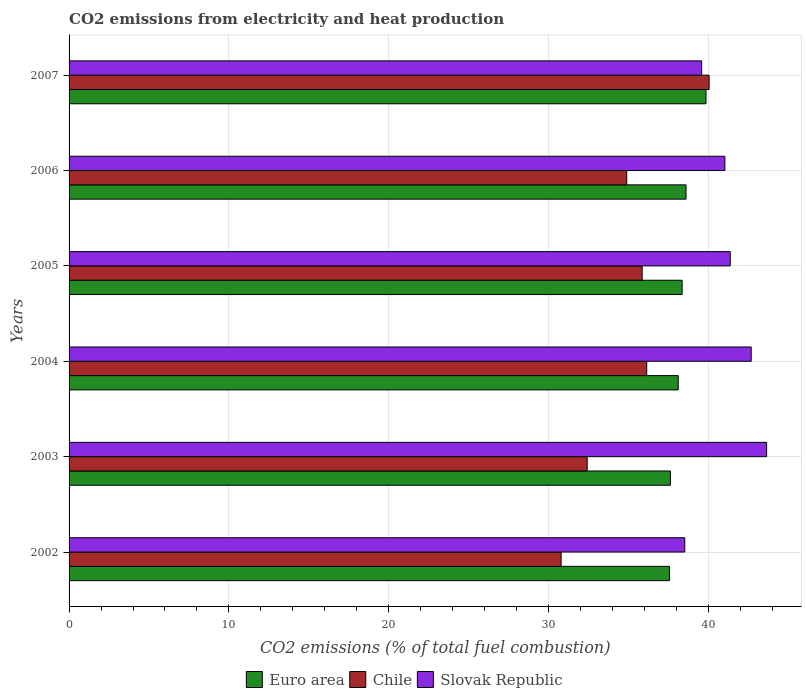How many groups of bars are there?
Make the answer very short. 6. Are the number of bars on each tick of the Y-axis equal?
Ensure brevity in your answer.  Yes. How many bars are there on the 1st tick from the top?
Make the answer very short. 3. What is the label of the 5th group of bars from the top?
Offer a very short reply. 2003. What is the amount of CO2 emitted in Euro area in 2003?
Ensure brevity in your answer.  37.62. Across all years, what is the maximum amount of CO2 emitted in Euro area?
Your answer should be compact. 39.85. Across all years, what is the minimum amount of CO2 emitted in Euro area?
Give a very brief answer. 37.57. In which year was the amount of CO2 emitted in Slovak Republic minimum?
Offer a terse response. 2002. What is the total amount of CO2 emitted in Chile in the graph?
Your response must be concise. 210.12. What is the difference between the amount of CO2 emitted in Slovak Republic in 2002 and that in 2006?
Offer a very short reply. -2.51. What is the difference between the amount of CO2 emitted in Euro area in 2004 and the amount of CO2 emitted in Slovak Republic in 2006?
Your answer should be very brief. -2.92. What is the average amount of CO2 emitted in Euro area per year?
Your answer should be compact. 38.35. In the year 2006, what is the difference between the amount of CO2 emitted in Euro area and amount of CO2 emitted in Slovak Republic?
Give a very brief answer. -2.43. What is the ratio of the amount of CO2 emitted in Slovak Republic in 2003 to that in 2006?
Your answer should be very brief. 1.06. Is the amount of CO2 emitted in Slovak Republic in 2004 less than that in 2007?
Make the answer very short. No. Is the difference between the amount of CO2 emitted in Euro area in 2002 and 2003 greater than the difference between the amount of CO2 emitted in Slovak Republic in 2002 and 2003?
Offer a terse response. Yes. What is the difference between the highest and the second highest amount of CO2 emitted in Euro area?
Offer a terse response. 1.25. What is the difference between the highest and the lowest amount of CO2 emitted in Euro area?
Ensure brevity in your answer.  2.28. In how many years, is the amount of CO2 emitted in Euro area greater than the average amount of CO2 emitted in Euro area taken over all years?
Offer a terse response. 3. Is the sum of the amount of CO2 emitted in Slovak Republic in 2003 and 2006 greater than the maximum amount of CO2 emitted in Euro area across all years?
Your answer should be very brief. Yes. What does the 1st bar from the top in 2005 represents?
Your answer should be very brief. Slovak Republic. What does the 3rd bar from the bottom in 2003 represents?
Your answer should be compact. Slovak Republic. Where does the legend appear in the graph?
Give a very brief answer. Bottom center. How many legend labels are there?
Your answer should be compact. 3. How are the legend labels stacked?
Keep it short and to the point. Horizontal. What is the title of the graph?
Offer a very short reply. CO2 emissions from electricity and heat production. What is the label or title of the X-axis?
Provide a succinct answer. CO2 emissions (% of total fuel combustion). What is the CO2 emissions (% of total fuel combustion) in Euro area in 2002?
Give a very brief answer. 37.57. What is the CO2 emissions (% of total fuel combustion) of Chile in 2002?
Your answer should be compact. 30.78. What is the CO2 emissions (% of total fuel combustion) in Slovak Republic in 2002?
Provide a succinct answer. 38.52. What is the CO2 emissions (% of total fuel combustion) of Euro area in 2003?
Make the answer very short. 37.62. What is the CO2 emissions (% of total fuel combustion) of Chile in 2003?
Your answer should be compact. 32.42. What is the CO2 emissions (% of total fuel combustion) of Slovak Republic in 2003?
Offer a very short reply. 43.64. What is the CO2 emissions (% of total fuel combustion) of Euro area in 2004?
Offer a terse response. 38.11. What is the CO2 emissions (% of total fuel combustion) of Chile in 2004?
Provide a short and direct response. 36.14. What is the CO2 emissions (% of total fuel combustion) in Slovak Republic in 2004?
Provide a succinct answer. 42.68. What is the CO2 emissions (% of total fuel combustion) in Euro area in 2005?
Offer a very short reply. 38.36. What is the CO2 emissions (% of total fuel combustion) in Chile in 2005?
Provide a succinct answer. 35.85. What is the CO2 emissions (% of total fuel combustion) in Slovak Republic in 2005?
Your response must be concise. 41.36. What is the CO2 emissions (% of total fuel combustion) of Euro area in 2006?
Offer a very short reply. 38.6. What is the CO2 emissions (% of total fuel combustion) of Chile in 2006?
Provide a short and direct response. 34.89. What is the CO2 emissions (% of total fuel combustion) in Slovak Republic in 2006?
Your answer should be compact. 41.03. What is the CO2 emissions (% of total fuel combustion) of Euro area in 2007?
Offer a very short reply. 39.85. What is the CO2 emissions (% of total fuel combustion) of Chile in 2007?
Provide a succinct answer. 40.04. What is the CO2 emissions (% of total fuel combustion) of Slovak Republic in 2007?
Give a very brief answer. 39.58. Across all years, what is the maximum CO2 emissions (% of total fuel combustion) of Euro area?
Offer a very short reply. 39.85. Across all years, what is the maximum CO2 emissions (% of total fuel combustion) in Chile?
Keep it short and to the point. 40.04. Across all years, what is the maximum CO2 emissions (% of total fuel combustion) of Slovak Republic?
Your answer should be very brief. 43.64. Across all years, what is the minimum CO2 emissions (% of total fuel combustion) in Euro area?
Keep it short and to the point. 37.57. Across all years, what is the minimum CO2 emissions (% of total fuel combustion) of Chile?
Ensure brevity in your answer.  30.78. Across all years, what is the minimum CO2 emissions (% of total fuel combustion) of Slovak Republic?
Provide a succinct answer. 38.52. What is the total CO2 emissions (% of total fuel combustion) in Euro area in the graph?
Make the answer very short. 230.1. What is the total CO2 emissions (% of total fuel combustion) in Chile in the graph?
Make the answer very short. 210.12. What is the total CO2 emissions (% of total fuel combustion) in Slovak Republic in the graph?
Give a very brief answer. 246.81. What is the difference between the CO2 emissions (% of total fuel combustion) in Euro area in 2002 and that in 2003?
Keep it short and to the point. -0.05. What is the difference between the CO2 emissions (% of total fuel combustion) of Chile in 2002 and that in 2003?
Give a very brief answer. -1.63. What is the difference between the CO2 emissions (% of total fuel combustion) of Slovak Republic in 2002 and that in 2003?
Ensure brevity in your answer.  -5.12. What is the difference between the CO2 emissions (% of total fuel combustion) in Euro area in 2002 and that in 2004?
Provide a succinct answer. -0.54. What is the difference between the CO2 emissions (% of total fuel combustion) in Chile in 2002 and that in 2004?
Your answer should be very brief. -5.36. What is the difference between the CO2 emissions (% of total fuel combustion) of Slovak Republic in 2002 and that in 2004?
Ensure brevity in your answer.  -4.16. What is the difference between the CO2 emissions (% of total fuel combustion) in Euro area in 2002 and that in 2005?
Offer a terse response. -0.79. What is the difference between the CO2 emissions (% of total fuel combustion) in Chile in 2002 and that in 2005?
Make the answer very short. -5.07. What is the difference between the CO2 emissions (% of total fuel combustion) of Slovak Republic in 2002 and that in 2005?
Your answer should be compact. -2.84. What is the difference between the CO2 emissions (% of total fuel combustion) of Euro area in 2002 and that in 2006?
Make the answer very short. -1.03. What is the difference between the CO2 emissions (% of total fuel combustion) of Chile in 2002 and that in 2006?
Your answer should be compact. -4.1. What is the difference between the CO2 emissions (% of total fuel combustion) in Slovak Republic in 2002 and that in 2006?
Ensure brevity in your answer.  -2.51. What is the difference between the CO2 emissions (% of total fuel combustion) in Euro area in 2002 and that in 2007?
Keep it short and to the point. -2.28. What is the difference between the CO2 emissions (% of total fuel combustion) of Chile in 2002 and that in 2007?
Provide a succinct answer. -9.26. What is the difference between the CO2 emissions (% of total fuel combustion) of Slovak Republic in 2002 and that in 2007?
Keep it short and to the point. -1.06. What is the difference between the CO2 emissions (% of total fuel combustion) in Euro area in 2003 and that in 2004?
Offer a terse response. -0.49. What is the difference between the CO2 emissions (% of total fuel combustion) in Chile in 2003 and that in 2004?
Keep it short and to the point. -3.72. What is the difference between the CO2 emissions (% of total fuel combustion) in Slovak Republic in 2003 and that in 2004?
Provide a succinct answer. 0.96. What is the difference between the CO2 emissions (% of total fuel combustion) in Euro area in 2003 and that in 2005?
Provide a short and direct response. -0.73. What is the difference between the CO2 emissions (% of total fuel combustion) of Chile in 2003 and that in 2005?
Keep it short and to the point. -3.44. What is the difference between the CO2 emissions (% of total fuel combustion) of Slovak Republic in 2003 and that in 2005?
Offer a very short reply. 2.28. What is the difference between the CO2 emissions (% of total fuel combustion) in Euro area in 2003 and that in 2006?
Provide a short and direct response. -0.98. What is the difference between the CO2 emissions (% of total fuel combustion) of Chile in 2003 and that in 2006?
Keep it short and to the point. -2.47. What is the difference between the CO2 emissions (% of total fuel combustion) in Slovak Republic in 2003 and that in 2006?
Offer a terse response. 2.61. What is the difference between the CO2 emissions (% of total fuel combustion) in Euro area in 2003 and that in 2007?
Give a very brief answer. -2.23. What is the difference between the CO2 emissions (% of total fuel combustion) of Chile in 2003 and that in 2007?
Your response must be concise. -7.63. What is the difference between the CO2 emissions (% of total fuel combustion) of Slovak Republic in 2003 and that in 2007?
Provide a short and direct response. 4.06. What is the difference between the CO2 emissions (% of total fuel combustion) of Euro area in 2004 and that in 2005?
Keep it short and to the point. -0.24. What is the difference between the CO2 emissions (% of total fuel combustion) in Chile in 2004 and that in 2005?
Make the answer very short. 0.29. What is the difference between the CO2 emissions (% of total fuel combustion) in Slovak Republic in 2004 and that in 2005?
Ensure brevity in your answer.  1.31. What is the difference between the CO2 emissions (% of total fuel combustion) in Euro area in 2004 and that in 2006?
Your answer should be very brief. -0.49. What is the difference between the CO2 emissions (% of total fuel combustion) in Chile in 2004 and that in 2006?
Your response must be concise. 1.25. What is the difference between the CO2 emissions (% of total fuel combustion) in Slovak Republic in 2004 and that in 2006?
Provide a succinct answer. 1.65. What is the difference between the CO2 emissions (% of total fuel combustion) of Euro area in 2004 and that in 2007?
Make the answer very short. -1.74. What is the difference between the CO2 emissions (% of total fuel combustion) in Chile in 2004 and that in 2007?
Your answer should be very brief. -3.9. What is the difference between the CO2 emissions (% of total fuel combustion) of Slovak Republic in 2004 and that in 2007?
Provide a short and direct response. 3.1. What is the difference between the CO2 emissions (% of total fuel combustion) of Euro area in 2005 and that in 2006?
Ensure brevity in your answer.  -0.24. What is the difference between the CO2 emissions (% of total fuel combustion) of Chile in 2005 and that in 2006?
Make the answer very short. 0.97. What is the difference between the CO2 emissions (% of total fuel combustion) of Slovak Republic in 2005 and that in 2006?
Your answer should be compact. 0.33. What is the difference between the CO2 emissions (% of total fuel combustion) of Euro area in 2005 and that in 2007?
Offer a very short reply. -1.49. What is the difference between the CO2 emissions (% of total fuel combustion) of Chile in 2005 and that in 2007?
Your response must be concise. -4.19. What is the difference between the CO2 emissions (% of total fuel combustion) in Slovak Republic in 2005 and that in 2007?
Your response must be concise. 1.79. What is the difference between the CO2 emissions (% of total fuel combustion) of Euro area in 2006 and that in 2007?
Keep it short and to the point. -1.25. What is the difference between the CO2 emissions (% of total fuel combustion) in Chile in 2006 and that in 2007?
Your answer should be very brief. -5.16. What is the difference between the CO2 emissions (% of total fuel combustion) of Slovak Republic in 2006 and that in 2007?
Make the answer very short. 1.45. What is the difference between the CO2 emissions (% of total fuel combustion) in Euro area in 2002 and the CO2 emissions (% of total fuel combustion) in Chile in 2003?
Provide a succinct answer. 5.15. What is the difference between the CO2 emissions (% of total fuel combustion) in Euro area in 2002 and the CO2 emissions (% of total fuel combustion) in Slovak Republic in 2003?
Your response must be concise. -6.07. What is the difference between the CO2 emissions (% of total fuel combustion) of Chile in 2002 and the CO2 emissions (% of total fuel combustion) of Slovak Republic in 2003?
Your answer should be compact. -12.86. What is the difference between the CO2 emissions (% of total fuel combustion) of Euro area in 2002 and the CO2 emissions (% of total fuel combustion) of Chile in 2004?
Ensure brevity in your answer.  1.43. What is the difference between the CO2 emissions (% of total fuel combustion) of Euro area in 2002 and the CO2 emissions (% of total fuel combustion) of Slovak Republic in 2004?
Make the answer very short. -5.11. What is the difference between the CO2 emissions (% of total fuel combustion) of Chile in 2002 and the CO2 emissions (% of total fuel combustion) of Slovak Republic in 2004?
Offer a very short reply. -11.89. What is the difference between the CO2 emissions (% of total fuel combustion) in Euro area in 2002 and the CO2 emissions (% of total fuel combustion) in Chile in 2005?
Provide a succinct answer. 1.71. What is the difference between the CO2 emissions (% of total fuel combustion) of Euro area in 2002 and the CO2 emissions (% of total fuel combustion) of Slovak Republic in 2005?
Ensure brevity in your answer.  -3.8. What is the difference between the CO2 emissions (% of total fuel combustion) in Chile in 2002 and the CO2 emissions (% of total fuel combustion) in Slovak Republic in 2005?
Your answer should be very brief. -10.58. What is the difference between the CO2 emissions (% of total fuel combustion) of Euro area in 2002 and the CO2 emissions (% of total fuel combustion) of Chile in 2006?
Provide a succinct answer. 2.68. What is the difference between the CO2 emissions (% of total fuel combustion) of Euro area in 2002 and the CO2 emissions (% of total fuel combustion) of Slovak Republic in 2006?
Provide a short and direct response. -3.46. What is the difference between the CO2 emissions (% of total fuel combustion) in Chile in 2002 and the CO2 emissions (% of total fuel combustion) in Slovak Republic in 2006?
Provide a short and direct response. -10.25. What is the difference between the CO2 emissions (% of total fuel combustion) in Euro area in 2002 and the CO2 emissions (% of total fuel combustion) in Chile in 2007?
Keep it short and to the point. -2.48. What is the difference between the CO2 emissions (% of total fuel combustion) in Euro area in 2002 and the CO2 emissions (% of total fuel combustion) in Slovak Republic in 2007?
Provide a succinct answer. -2.01. What is the difference between the CO2 emissions (% of total fuel combustion) of Chile in 2002 and the CO2 emissions (% of total fuel combustion) of Slovak Republic in 2007?
Ensure brevity in your answer.  -8.79. What is the difference between the CO2 emissions (% of total fuel combustion) of Euro area in 2003 and the CO2 emissions (% of total fuel combustion) of Chile in 2004?
Keep it short and to the point. 1.48. What is the difference between the CO2 emissions (% of total fuel combustion) in Euro area in 2003 and the CO2 emissions (% of total fuel combustion) in Slovak Republic in 2004?
Provide a short and direct response. -5.06. What is the difference between the CO2 emissions (% of total fuel combustion) in Chile in 2003 and the CO2 emissions (% of total fuel combustion) in Slovak Republic in 2004?
Ensure brevity in your answer.  -10.26. What is the difference between the CO2 emissions (% of total fuel combustion) of Euro area in 2003 and the CO2 emissions (% of total fuel combustion) of Chile in 2005?
Ensure brevity in your answer.  1.77. What is the difference between the CO2 emissions (% of total fuel combustion) in Euro area in 2003 and the CO2 emissions (% of total fuel combustion) in Slovak Republic in 2005?
Offer a very short reply. -3.74. What is the difference between the CO2 emissions (% of total fuel combustion) of Chile in 2003 and the CO2 emissions (% of total fuel combustion) of Slovak Republic in 2005?
Your response must be concise. -8.95. What is the difference between the CO2 emissions (% of total fuel combustion) in Euro area in 2003 and the CO2 emissions (% of total fuel combustion) in Chile in 2006?
Your response must be concise. 2.73. What is the difference between the CO2 emissions (% of total fuel combustion) of Euro area in 2003 and the CO2 emissions (% of total fuel combustion) of Slovak Republic in 2006?
Ensure brevity in your answer.  -3.41. What is the difference between the CO2 emissions (% of total fuel combustion) of Chile in 2003 and the CO2 emissions (% of total fuel combustion) of Slovak Republic in 2006?
Keep it short and to the point. -8.62. What is the difference between the CO2 emissions (% of total fuel combustion) of Euro area in 2003 and the CO2 emissions (% of total fuel combustion) of Chile in 2007?
Ensure brevity in your answer.  -2.42. What is the difference between the CO2 emissions (% of total fuel combustion) in Euro area in 2003 and the CO2 emissions (% of total fuel combustion) in Slovak Republic in 2007?
Provide a succinct answer. -1.96. What is the difference between the CO2 emissions (% of total fuel combustion) of Chile in 2003 and the CO2 emissions (% of total fuel combustion) of Slovak Republic in 2007?
Ensure brevity in your answer.  -7.16. What is the difference between the CO2 emissions (% of total fuel combustion) of Euro area in 2004 and the CO2 emissions (% of total fuel combustion) of Chile in 2005?
Offer a very short reply. 2.26. What is the difference between the CO2 emissions (% of total fuel combustion) in Euro area in 2004 and the CO2 emissions (% of total fuel combustion) in Slovak Republic in 2005?
Give a very brief answer. -3.25. What is the difference between the CO2 emissions (% of total fuel combustion) of Chile in 2004 and the CO2 emissions (% of total fuel combustion) of Slovak Republic in 2005?
Give a very brief answer. -5.22. What is the difference between the CO2 emissions (% of total fuel combustion) in Euro area in 2004 and the CO2 emissions (% of total fuel combustion) in Chile in 2006?
Your answer should be compact. 3.22. What is the difference between the CO2 emissions (% of total fuel combustion) in Euro area in 2004 and the CO2 emissions (% of total fuel combustion) in Slovak Republic in 2006?
Your response must be concise. -2.92. What is the difference between the CO2 emissions (% of total fuel combustion) of Chile in 2004 and the CO2 emissions (% of total fuel combustion) of Slovak Republic in 2006?
Provide a succinct answer. -4.89. What is the difference between the CO2 emissions (% of total fuel combustion) in Euro area in 2004 and the CO2 emissions (% of total fuel combustion) in Chile in 2007?
Keep it short and to the point. -1.93. What is the difference between the CO2 emissions (% of total fuel combustion) of Euro area in 2004 and the CO2 emissions (% of total fuel combustion) of Slovak Republic in 2007?
Provide a succinct answer. -1.47. What is the difference between the CO2 emissions (% of total fuel combustion) of Chile in 2004 and the CO2 emissions (% of total fuel combustion) of Slovak Republic in 2007?
Your answer should be compact. -3.44. What is the difference between the CO2 emissions (% of total fuel combustion) in Euro area in 2005 and the CO2 emissions (% of total fuel combustion) in Chile in 2006?
Make the answer very short. 3.47. What is the difference between the CO2 emissions (% of total fuel combustion) of Euro area in 2005 and the CO2 emissions (% of total fuel combustion) of Slovak Republic in 2006?
Make the answer very short. -2.68. What is the difference between the CO2 emissions (% of total fuel combustion) in Chile in 2005 and the CO2 emissions (% of total fuel combustion) in Slovak Republic in 2006?
Provide a succinct answer. -5.18. What is the difference between the CO2 emissions (% of total fuel combustion) of Euro area in 2005 and the CO2 emissions (% of total fuel combustion) of Chile in 2007?
Provide a succinct answer. -1.69. What is the difference between the CO2 emissions (% of total fuel combustion) of Euro area in 2005 and the CO2 emissions (% of total fuel combustion) of Slovak Republic in 2007?
Offer a very short reply. -1.22. What is the difference between the CO2 emissions (% of total fuel combustion) in Chile in 2005 and the CO2 emissions (% of total fuel combustion) in Slovak Republic in 2007?
Offer a very short reply. -3.72. What is the difference between the CO2 emissions (% of total fuel combustion) of Euro area in 2006 and the CO2 emissions (% of total fuel combustion) of Chile in 2007?
Offer a very short reply. -1.44. What is the difference between the CO2 emissions (% of total fuel combustion) in Euro area in 2006 and the CO2 emissions (% of total fuel combustion) in Slovak Republic in 2007?
Your answer should be very brief. -0.98. What is the difference between the CO2 emissions (% of total fuel combustion) of Chile in 2006 and the CO2 emissions (% of total fuel combustion) of Slovak Republic in 2007?
Keep it short and to the point. -4.69. What is the average CO2 emissions (% of total fuel combustion) of Euro area per year?
Provide a short and direct response. 38.35. What is the average CO2 emissions (% of total fuel combustion) in Chile per year?
Your response must be concise. 35.02. What is the average CO2 emissions (% of total fuel combustion) of Slovak Republic per year?
Offer a very short reply. 41.14. In the year 2002, what is the difference between the CO2 emissions (% of total fuel combustion) of Euro area and CO2 emissions (% of total fuel combustion) of Chile?
Provide a succinct answer. 6.78. In the year 2002, what is the difference between the CO2 emissions (% of total fuel combustion) in Euro area and CO2 emissions (% of total fuel combustion) in Slovak Republic?
Give a very brief answer. -0.95. In the year 2002, what is the difference between the CO2 emissions (% of total fuel combustion) of Chile and CO2 emissions (% of total fuel combustion) of Slovak Republic?
Offer a terse response. -7.74. In the year 2003, what is the difference between the CO2 emissions (% of total fuel combustion) in Euro area and CO2 emissions (% of total fuel combustion) in Chile?
Provide a succinct answer. 5.21. In the year 2003, what is the difference between the CO2 emissions (% of total fuel combustion) of Euro area and CO2 emissions (% of total fuel combustion) of Slovak Republic?
Your response must be concise. -6.02. In the year 2003, what is the difference between the CO2 emissions (% of total fuel combustion) of Chile and CO2 emissions (% of total fuel combustion) of Slovak Republic?
Your answer should be compact. -11.23. In the year 2004, what is the difference between the CO2 emissions (% of total fuel combustion) of Euro area and CO2 emissions (% of total fuel combustion) of Chile?
Your answer should be compact. 1.97. In the year 2004, what is the difference between the CO2 emissions (% of total fuel combustion) of Euro area and CO2 emissions (% of total fuel combustion) of Slovak Republic?
Give a very brief answer. -4.57. In the year 2004, what is the difference between the CO2 emissions (% of total fuel combustion) in Chile and CO2 emissions (% of total fuel combustion) in Slovak Republic?
Ensure brevity in your answer.  -6.54. In the year 2005, what is the difference between the CO2 emissions (% of total fuel combustion) in Euro area and CO2 emissions (% of total fuel combustion) in Chile?
Your answer should be very brief. 2.5. In the year 2005, what is the difference between the CO2 emissions (% of total fuel combustion) in Euro area and CO2 emissions (% of total fuel combustion) in Slovak Republic?
Give a very brief answer. -3.01. In the year 2005, what is the difference between the CO2 emissions (% of total fuel combustion) in Chile and CO2 emissions (% of total fuel combustion) in Slovak Republic?
Your answer should be compact. -5.51. In the year 2006, what is the difference between the CO2 emissions (% of total fuel combustion) of Euro area and CO2 emissions (% of total fuel combustion) of Chile?
Your answer should be compact. 3.71. In the year 2006, what is the difference between the CO2 emissions (% of total fuel combustion) in Euro area and CO2 emissions (% of total fuel combustion) in Slovak Republic?
Keep it short and to the point. -2.43. In the year 2006, what is the difference between the CO2 emissions (% of total fuel combustion) of Chile and CO2 emissions (% of total fuel combustion) of Slovak Republic?
Provide a short and direct response. -6.14. In the year 2007, what is the difference between the CO2 emissions (% of total fuel combustion) of Euro area and CO2 emissions (% of total fuel combustion) of Chile?
Give a very brief answer. -0.19. In the year 2007, what is the difference between the CO2 emissions (% of total fuel combustion) of Euro area and CO2 emissions (% of total fuel combustion) of Slovak Republic?
Offer a terse response. 0.27. In the year 2007, what is the difference between the CO2 emissions (% of total fuel combustion) of Chile and CO2 emissions (% of total fuel combustion) of Slovak Republic?
Make the answer very short. 0.47. What is the ratio of the CO2 emissions (% of total fuel combustion) in Euro area in 2002 to that in 2003?
Ensure brevity in your answer.  1. What is the ratio of the CO2 emissions (% of total fuel combustion) of Chile in 2002 to that in 2003?
Your response must be concise. 0.95. What is the ratio of the CO2 emissions (% of total fuel combustion) of Slovak Republic in 2002 to that in 2003?
Give a very brief answer. 0.88. What is the ratio of the CO2 emissions (% of total fuel combustion) of Euro area in 2002 to that in 2004?
Your answer should be very brief. 0.99. What is the ratio of the CO2 emissions (% of total fuel combustion) of Chile in 2002 to that in 2004?
Offer a terse response. 0.85. What is the ratio of the CO2 emissions (% of total fuel combustion) in Slovak Republic in 2002 to that in 2004?
Provide a succinct answer. 0.9. What is the ratio of the CO2 emissions (% of total fuel combustion) in Euro area in 2002 to that in 2005?
Provide a succinct answer. 0.98. What is the ratio of the CO2 emissions (% of total fuel combustion) in Chile in 2002 to that in 2005?
Your response must be concise. 0.86. What is the ratio of the CO2 emissions (% of total fuel combustion) in Slovak Republic in 2002 to that in 2005?
Keep it short and to the point. 0.93. What is the ratio of the CO2 emissions (% of total fuel combustion) of Euro area in 2002 to that in 2006?
Your answer should be very brief. 0.97. What is the ratio of the CO2 emissions (% of total fuel combustion) of Chile in 2002 to that in 2006?
Provide a short and direct response. 0.88. What is the ratio of the CO2 emissions (% of total fuel combustion) in Slovak Republic in 2002 to that in 2006?
Offer a terse response. 0.94. What is the ratio of the CO2 emissions (% of total fuel combustion) of Euro area in 2002 to that in 2007?
Ensure brevity in your answer.  0.94. What is the ratio of the CO2 emissions (% of total fuel combustion) in Chile in 2002 to that in 2007?
Your answer should be compact. 0.77. What is the ratio of the CO2 emissions (% of total fuel combustion) in Slovak Republic in 2002 to that in 2007?
Your response must be concise. 0.97. What is the ratio of the CO2 emissions (% of total fuel combustion) in Euro area in 2003 to that in 2004?
Your answer should be compact. 0.99. What is the ratio of the CO2 emissions (% of total fuel combustion) in Chile in 2003 to that in 2004?
Provide a succinct answer. 0.9. What is the ratio of the CO2 emissions (% of total fuel combustion) of Slovak Republic in 2003 to that in 2004?
Give a very brief answer. 1.02. What is the ratio of the CO2 emissions (% of total fuel combustion) of Euro area in 2003 to that in 2005?
Provide a short and direct response. 0.98. What is the ratio of the CO2 emissions (% of total fuel combustion) in Chile in 2003 to that in 2005?
Make the answer very short. 0.9. What is the ratio of the CO2 emissions (% of total fuel combustion) in Slovak Republic in 2003 to that in 2005?
Make the answer very short. 1.05. What is the ratio of the CO2 emissions (% of total fuel combustion) of Euro area in 2003 to that in 2006?
Your response must be concise. 0.97. What is the ratio of the CO2 emissions (% of total fuel combustion) of Chile in 2003 to that in 2006?
Ensure brevity in your answer.  0.93. What is the ratio of the CO2 emissions (% of total fuel combustion) in Slovak Republic in 2003 to that in 2006?
Provide a succinct answer. 1.06. What is the ratio of the CO2 emissions (% of total fuel combustion) in Euro area in 2003 to that in 2007?
Ensure brevity in your answer.  0.94. What is the ratio of the CO2 emissions (% of total fuel combustion) of Chile in 2003 to that in 2007?
Give a very brief answer. 0.81. What is the ratio of the CO2 emissions (% of total fuel combustion) of Slovak Republic in 2003 to that in 2007?
Give a very brief answer. 1.1. What is the ratio of the CO2 emissions (% of total fuel combustion) of Euro area in 2004 to that in 2005?
Make the answer very short. 0.99. What is the ratio of the CO2 emissions (% of total fuel combustion) in Chile in 2004 to that in 2005?
Ensure brevity in your answer.  1.01. What is the ratio of the CO2 emissions (% of total fuel combustion) in Slovak Republic in 2004 to that in 2005?
Your response must be concise. 1.03. What is the ratio of the CO2 emissions (% of total fuel combustion) of Euro area in 2004 to that in 2006?
Offer a terse response. 0.99. What is the ratio of the CO2 emissions (% of total fuel combustion) of Chile in 2004 to that in 2006?
Ensure brevity in your answer.  1.04. What is the ratio of the CO2 emissions (% of total fuel combustion) in Slovak Republic in 2004 to that in 2006?
Provide a short and direct response. 1.04. What is the ratio of the CO2 emissions (% of total fuel combustion) of Euro area in 2004 to that in 2007?
Ensure brevity in your answer.  0.96. What is the ratio of the CO2 emissions (% of total fuel combustion) of Chile in 2004 to that in 2007?
Your answer should be very brief. 0.9. What is the ratio of the CO2 emissions (% of total fuel combustion) in Slovak Republic in 2004 to that in 2007?
Make the answer very short. 1.08. What is the ratio of the CO2 emissions (% of total fuel combustion) of Euro area in 2005 to that in 2006?
Make the answer very short. 0.99. What is the ratio of the CO2 emissions (% of total fuel combustion) of Chile in 2005 to that in 2006?
Your answer should be very brief. 1.03. What is the ratio of the CO2 emissions (% of total fuel combustion) in Slovak Republic in 2005 to that in 2006?
Ensure brevity in your answer.  1.01. What is the ratio of the CO2 emissions (% of total fuel combustion) in Euro area in 2005 to that in 2007?
Offer a terse response. 0.96. What is the ratio of the CO2 emissions (% of total fuel combustion) of Chile in 2005 to that in 2007?
Your response must be concise. 0.9. What is the ratio of the CO2 emissions (% of total fuel combustion) of Slovak Republic in 2005 to that in 2007?
Your response must be concise. 1.05. What is the ratio of the CO2 emissions (% of total fuel combustion) in Euro area in 2006 to that in 2007?
Your response must be concise. 0.97. What is the ratio of the CO2 emissions (% of total fuel combustion) in Chile in 2006 to that in 2007?
Provide a short and direct response. 0.87. What is the ratio of the CO2 emissions (% of total fuel combustion) in Slovak Republic in 2006 to that in 2007?
Give a very brief answer. 1.04. What is the difference between the highest and the second highest CO2 emissions (% of total fuel combustion) of Euro area?
Ensure brevity in your answer.  1.25. What is the difference between the highest and the second highest CO2 emissions (% of total fuel combustion) of Chile?
Your answer should be compact. 3.9. What is the difference between the highest and the second highest CO2 emissions (% of total fuel combustion) in Slovak Republic?
Offer a terse response. 0.96. What is the difference between the highest and the lowest CO2 emissions (% of total fuel combustion) of Euro area?
Give a very brief answer. 2.28. What is the difference between the highest and the lowest CO2 emissions (% of total fuel combustion) in Chile?
Your answer should be compact. 9.26. What is the difference between the highest and the lowest CO2 emissions (% of total fuel combustion) in Slovak Republic?
Provide a short and direct response. 5.12. 